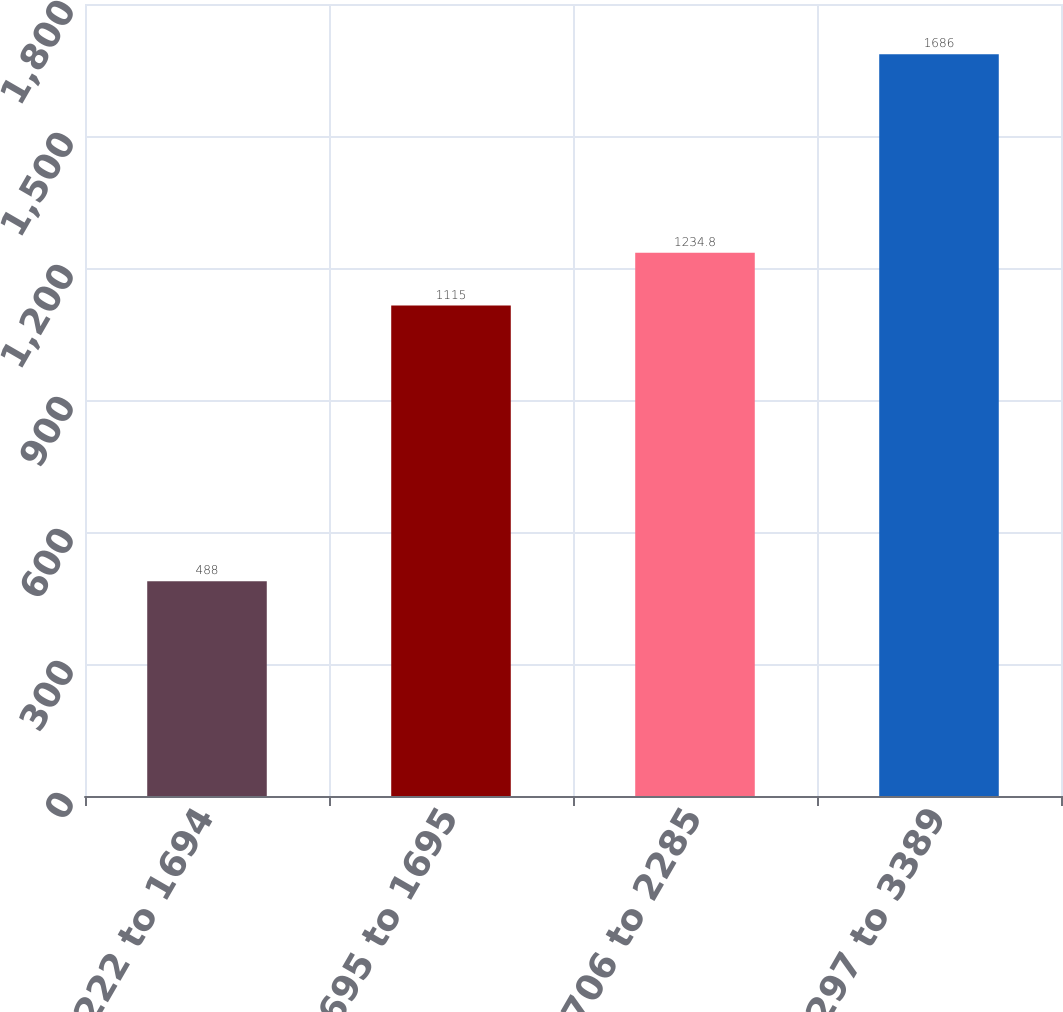Convert chart to OTSL. <chart><loc_0><loc_0><loc_500><loc_500><bar_chart><fcel>1222 to 1694<fcel>1695 to 1695<fcel>1706 to 2285<fcel>2297 to 3389<nl><fcel>488<fcel>1115<fcel>1234.8<fcel>1686<nl></chart> 